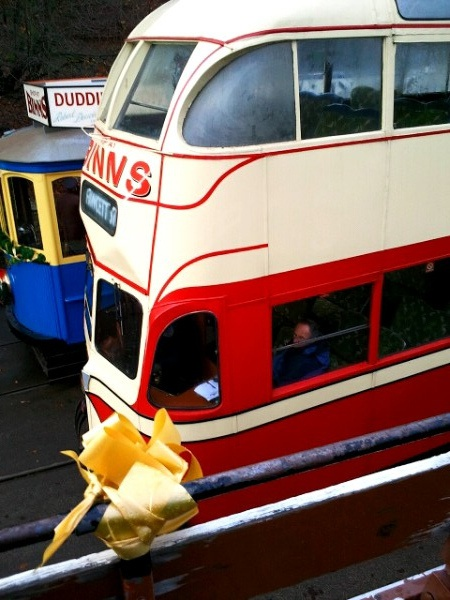Describe the objects in this image and their specific colors. I can see bus in black, ivory, maroon, and beige tones, train in black, lightgray, navy, and darkblue tones, bus in black, navy, darkblue, and blue tones, and people in black, maroon, navy, and brown tones in this image. 